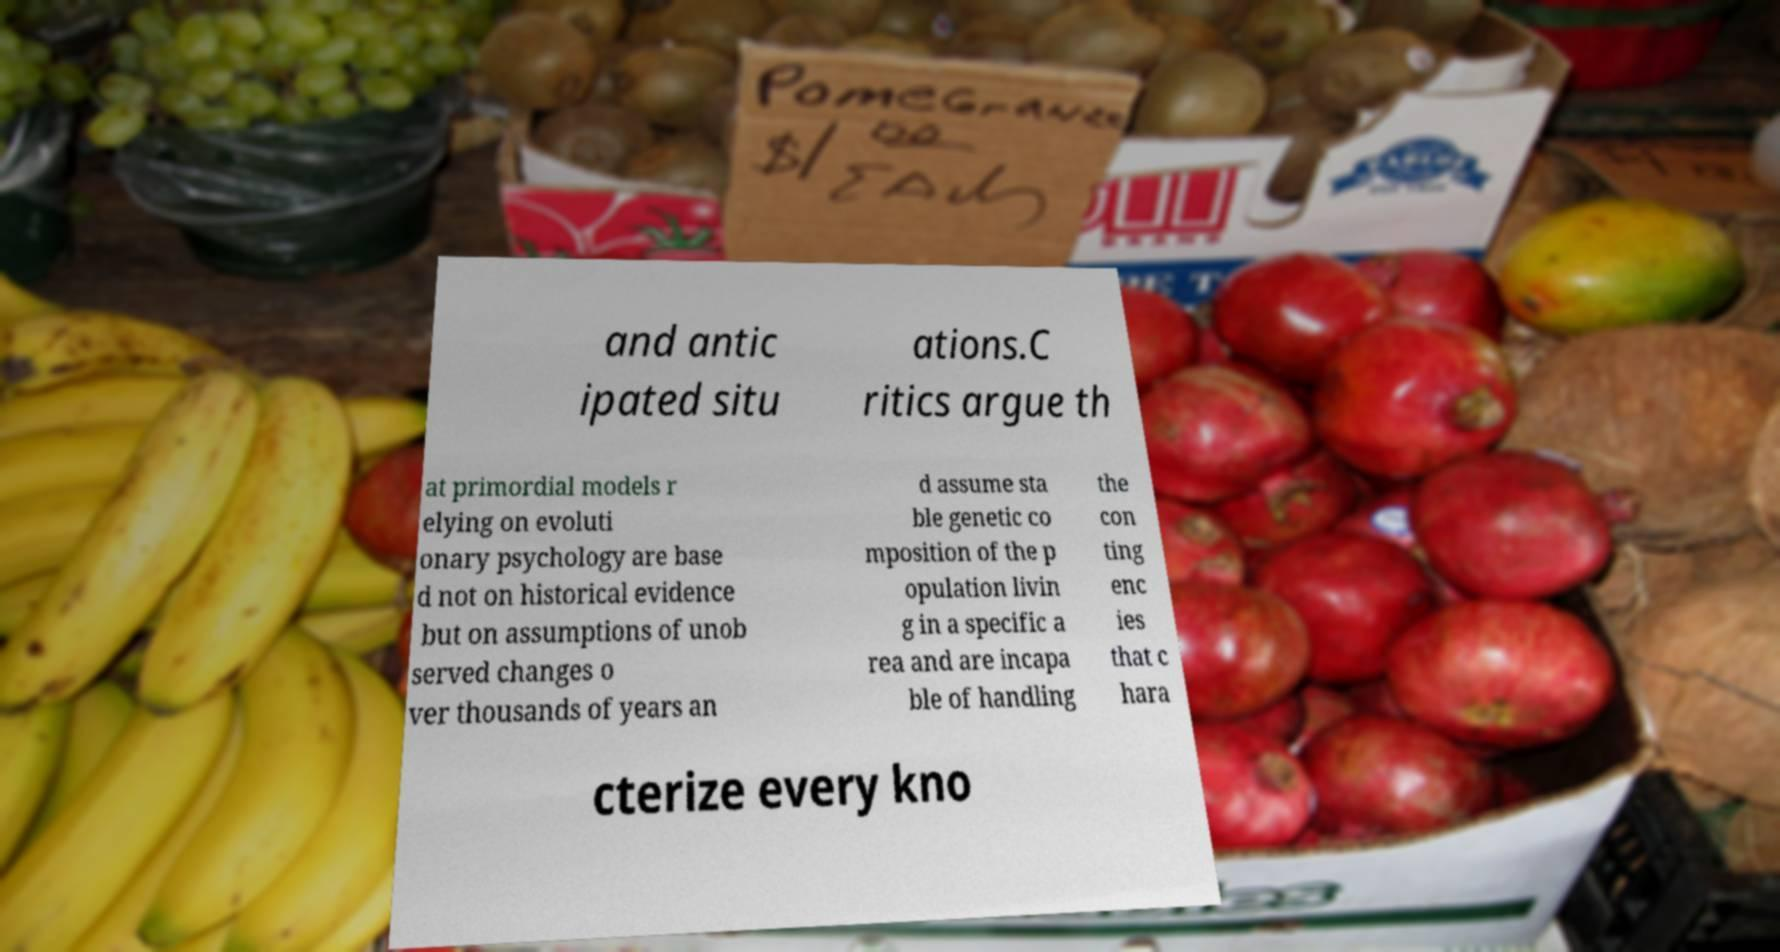Can you read and provide the text displayed in the image?This photo seems to have some interesting text. Can you extract and type it out for me? and antic ipated situ ations.C ritics argue th at primordial models r elying on evoluti onary psychology are base d not on historical evidence but on assumptions of unob served changes o ver thousands of years an d assume sta ble genetic co mposition of the p opulation livin g in a specific a rea and are incapa ble of handling the con ting enc ies that c hara cterize every kno 